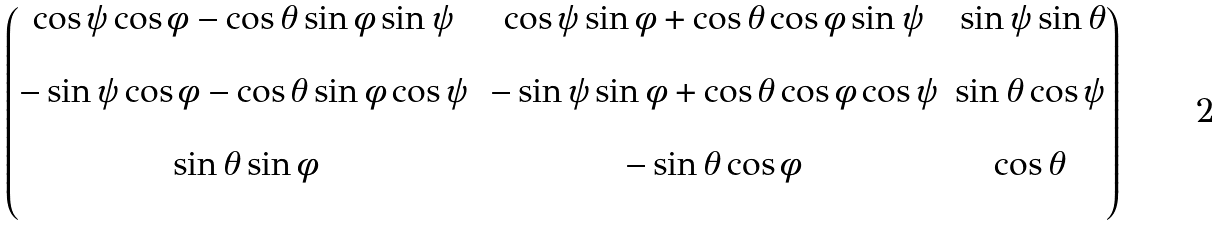<formula> <loc_0><loc_0><loc_500><loc_500>\begin{pmatrix} \cos \psi \cos \phi - \cos \theta \sin \phi \sin \psi \, & \, \cos \psi \sin \phi + \cos \theta \cos \phi \sin \psi \, & \, \sin \psi \sin \theta \\ \\ - \sin \psi \cos \phi - \cos \theta \sin \phi \cos \psi \, & - \sin \psi \sin \phi + \cos \theta \cos \phi \cos \psi & \sin \theta \cos \psi \\ \\ \sin \theta \sin \phi & - \sin \theta \cos \phi & \cos \theta \\ \\ \end{pmatrix}</formula> 